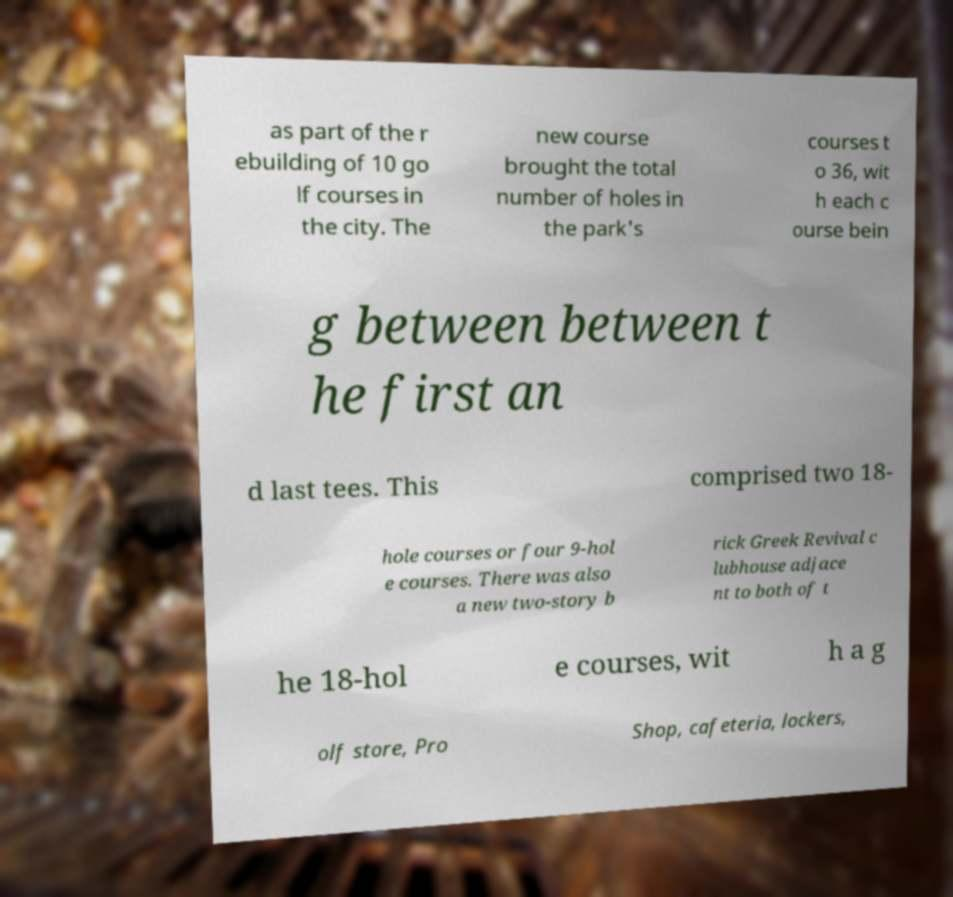Could you extract and type out the text from this image? as part of the r ebuilding of 10 go lf courses in the city. The new course brought the total number of holes in the park's courses t o 36, wit h each c ourse bein g between between t he first an d last tees. This comprised two 18- hole courses or four 9-hol e courses. There was also a new two-story b rick Greek Revival c lubhouse adjace nt to both of t he 18-hol e courses, wit h a g olf store, Pro Shop, cafeteria, lockers, 